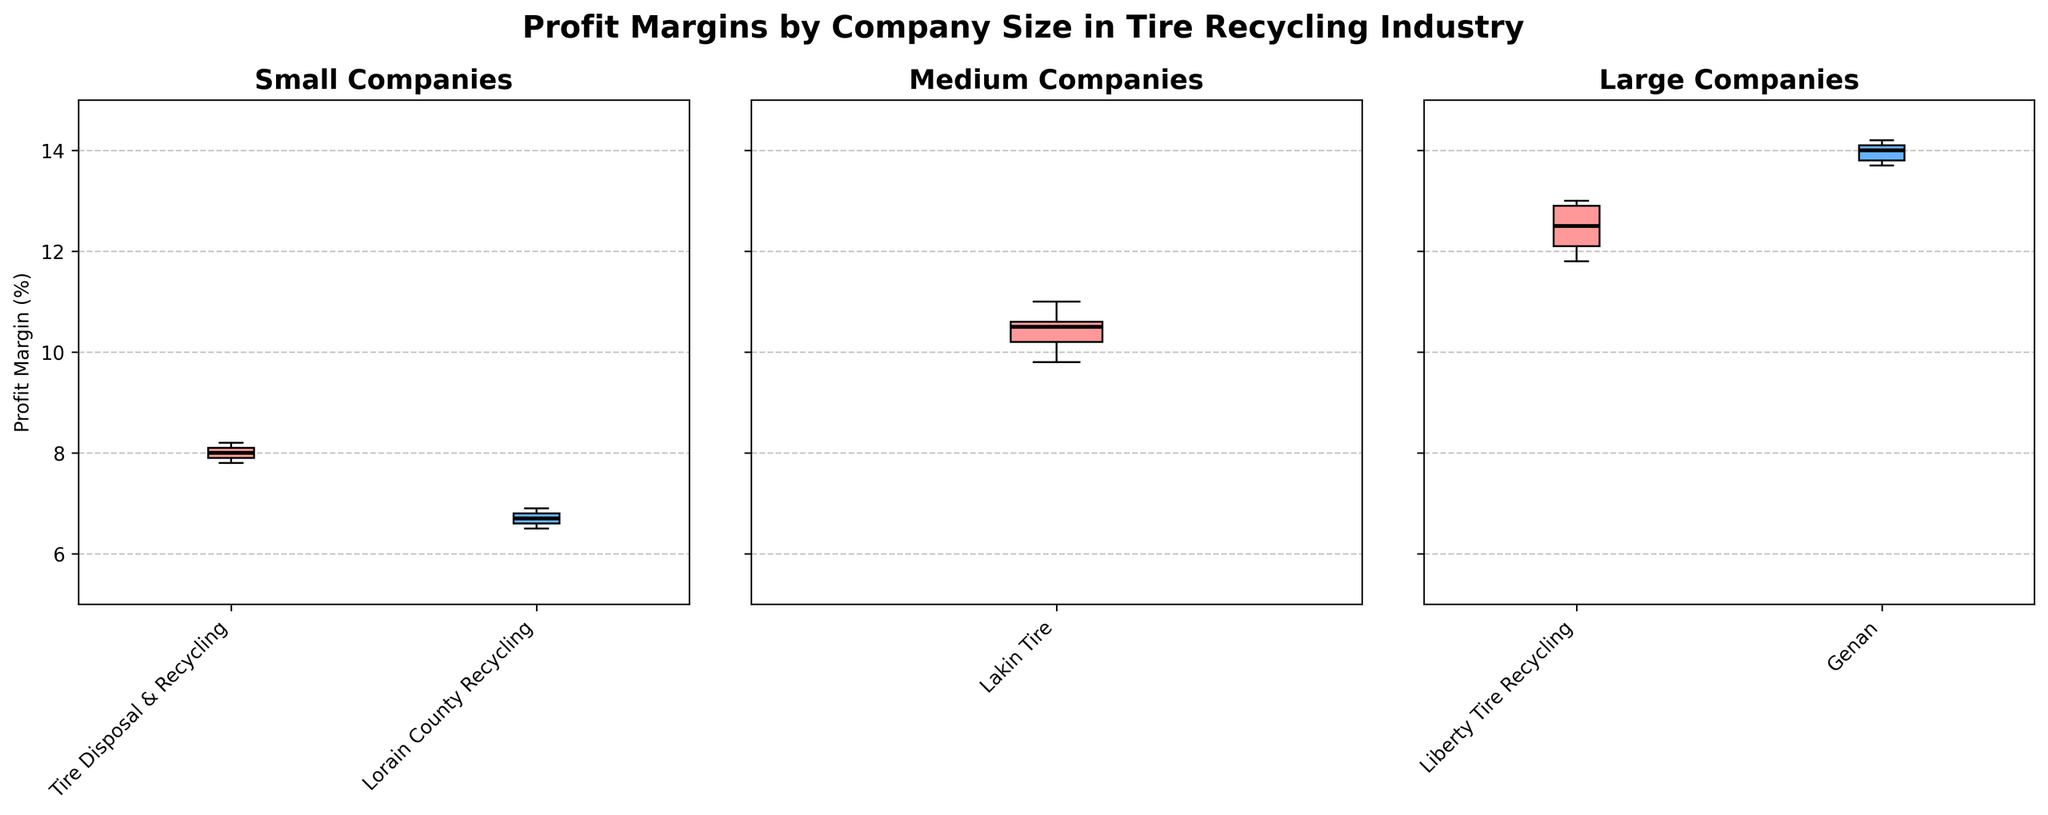What is the title of the figure? The title of the figure is prominently displayed at the top center. It reads "Profit Margins by Company Size in Tire Recycling Industry."
Answer: Profit Margins by Company Size in Tire Recycling Industry Which type of companies are shown in the first subplot on the left? The first subplot on the left is titled "Small Companies," indicating it contains data for small-sized companies.
Answer: Small Companies How many data points of profit margin are represented for "Lakin Tire"? "Lakin Tire" appears in the subplot for medium-sized companies. By counting the data points in the box plot for "Lakin Tire," there are 5 data points.
Answer: 5 Which size category has the highest median profit margin? By looking at the black median lines in the box plots, the large-sized category has the highest median profit margin, with Genan showing a higher median than Liberty Tire Recycling.
Answer: Large What is the range of profit margins for "Tire Disposal & Recycling"? The box plot for "Tire Disposal & Recycling" in the small companies subplot ranges from 7.8% to 8.2%. The interquartile range can be observed between these values.
Answer: 7.8% to 8.2% Compare the variability in profit margins between "Liberty Tire Recycling" and "Genan." Both companies are in the large category. "Liberty Tire Recycling" shows slightly more variability in profit margins with a broader interquartile range compared to "Genan," which has a narrower box plot, indicating less variability.
Answer: Liberty Tire Recycling has more variability Which small company has a lower median profit margin, "Tire Disposal & Recycling" or "Lorain County Recycling"? In the small companies subplot, the median line for "Lorain County Recycling" is lower than that of "Tire Disposal & Recycling."
Answer: Lorain County Recycling What is the approximate median profit margin for "Genan"? Observing the median line in the box plot for "Genan" in the large companies subplot, it is approximately at 14.0%.
Answer: 14.0% Compare the profit margin ranges of "Liberty Tire Recycling" and "Lakin Tire." Which one is broader? "Liberty Tire Recycling" has a profit margin range from 11.8% to 13.0%, whereas "Lakin Tire" has a profit margin range from 9.8% to 11.0%. Thus, "Liberty Tire Recycling" has a broader range.
Answer: Liberty Tire Recycling 